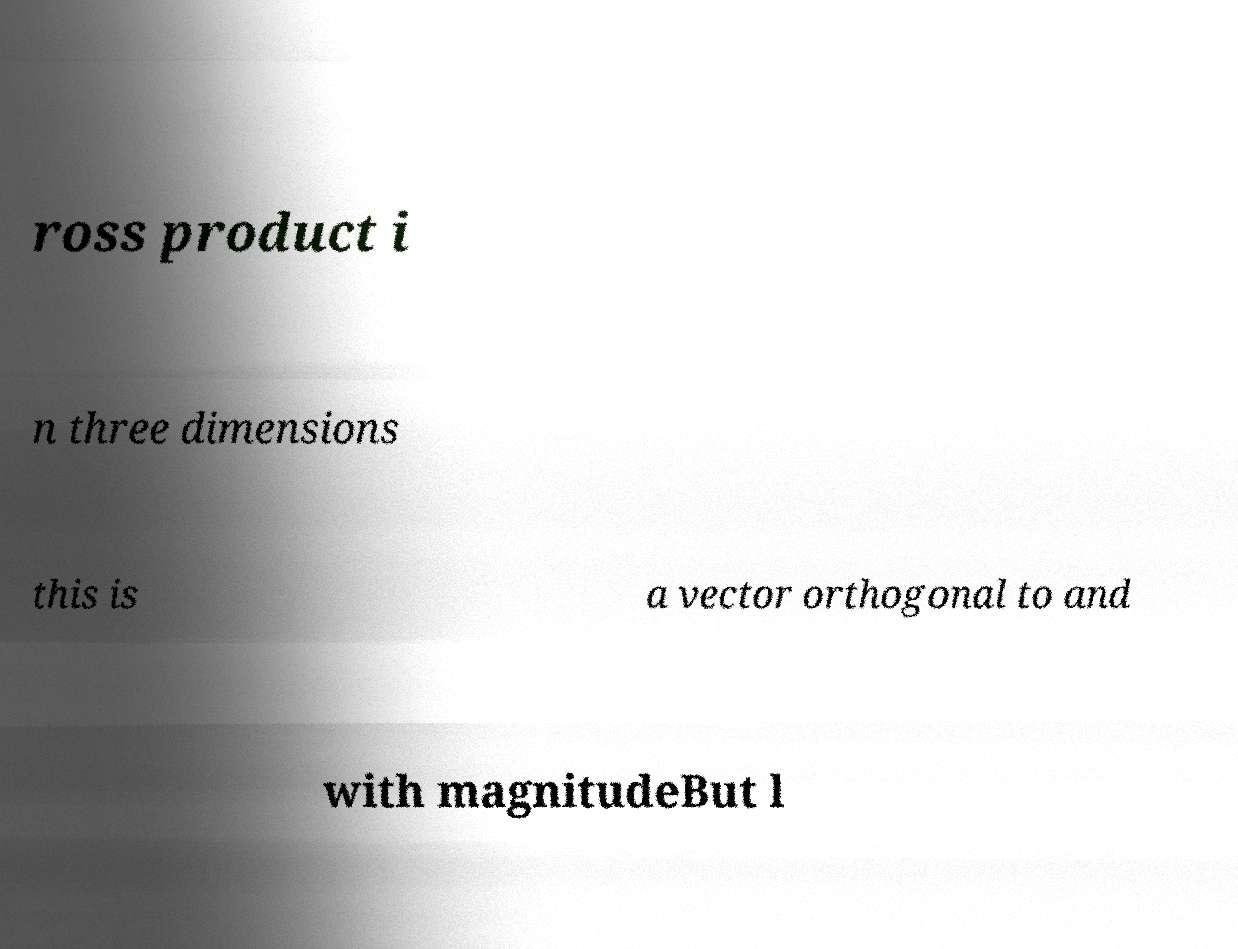Can you accurately transcribe the text from the provided image for me? ross product i n three dimensions this is a vector orthogonal to and with magnitudeBut l 